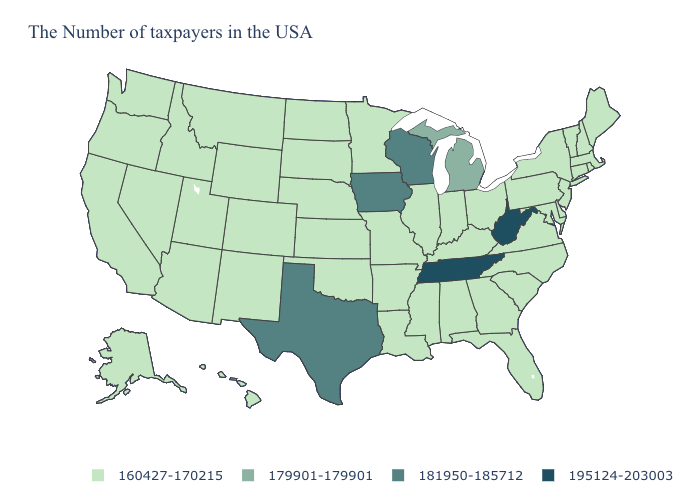Does Michigan have a higher value than Montana?
Short answer required. Yes. Which states have the highest value in the USA?
Write a very short answer. West Virginia, Tennessee. Name the states that have a value in the range 179901-179901?
Write a very short answer. Michigan. Which states have the highest value in the USA?
Quick response, please. West Virginia, Tennessee. Does West Virginia have a higher value than Nebraska?
Short answer required. Yes. What is the value of Pennsylvania?
Concise answer only. 160427-170215. Does Oregon have a lower value than Illinois?
Answer briefly. No. What is the value of Virginia?
Give a very brief answer. 160427-170215. How many symbols are there in the legend?
Give a very brief answer. 4. How many symbols are there in the legend?
Be succinct. 4. What is the value of Rhode Island?
Quick response, please. 160427-170215. What is the highest value in the USA?
Concise answer only. 195124-203003. What is the value of Utah?
Concise answer only. 160427-170215. 